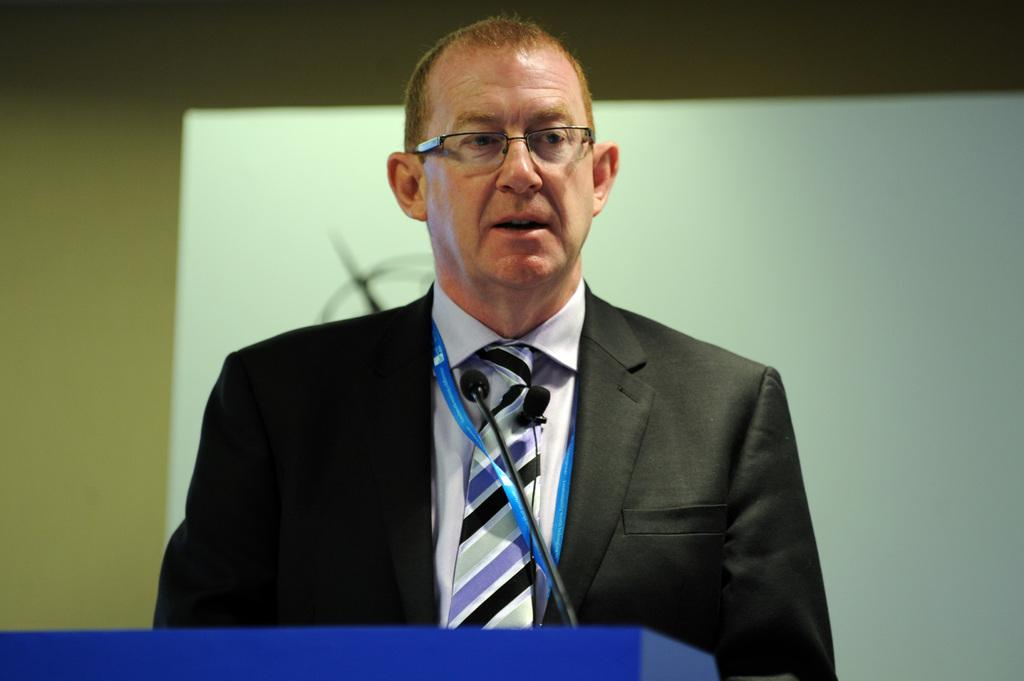Who is the main subject in the image? There is a man in the image. What is the man wearing? The man is wearing a black suit. What is the man doing in the image? The man is standing in front of a podium. What can be seen in the background of the image? There is a screen in the background of the image. What color is the screen? The screen is white in color. What type of maid is standing next to the man in the image? There is no maid present in the image. What items are listed on the screen in the image? There are no items listed on the screen in the image; it is white and does not display any text or content. 